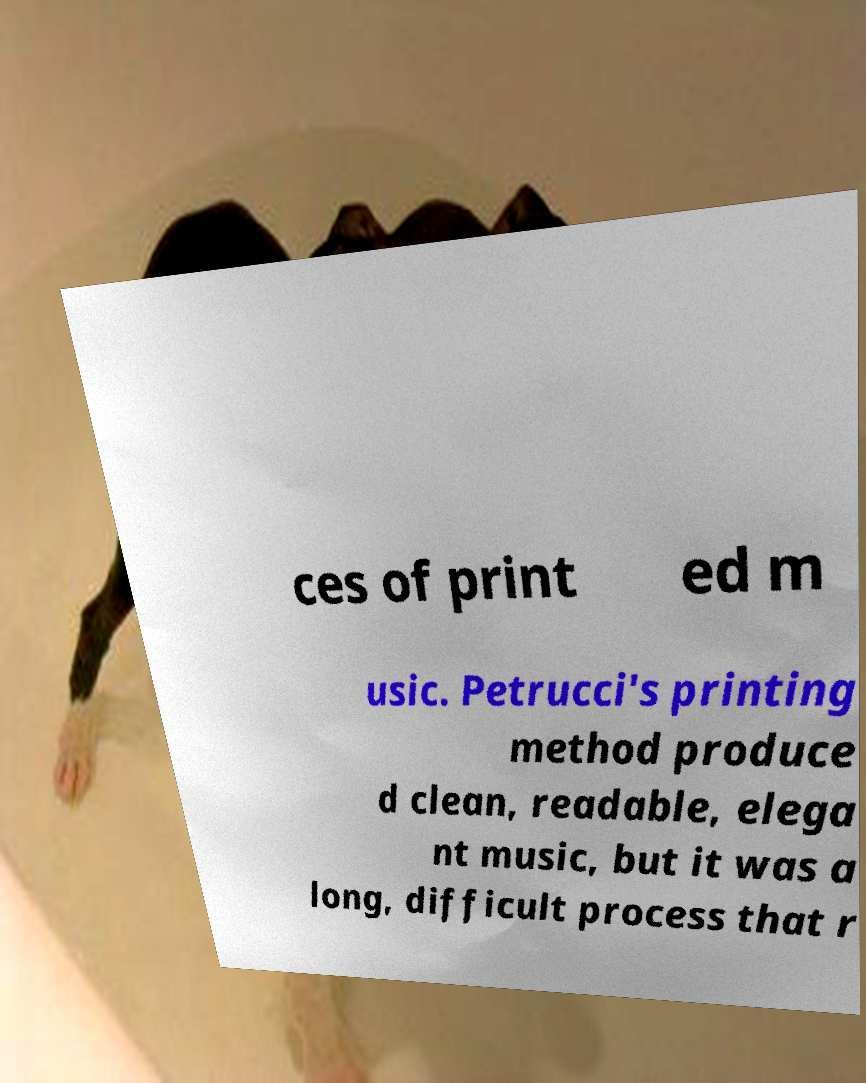Could you assist in decoding the text presented in this image and type it out clearly? ces of print ed m usic. Petrucci's printing method produce d clean, readable, elega nt music, but it was a long, difficult process that r 